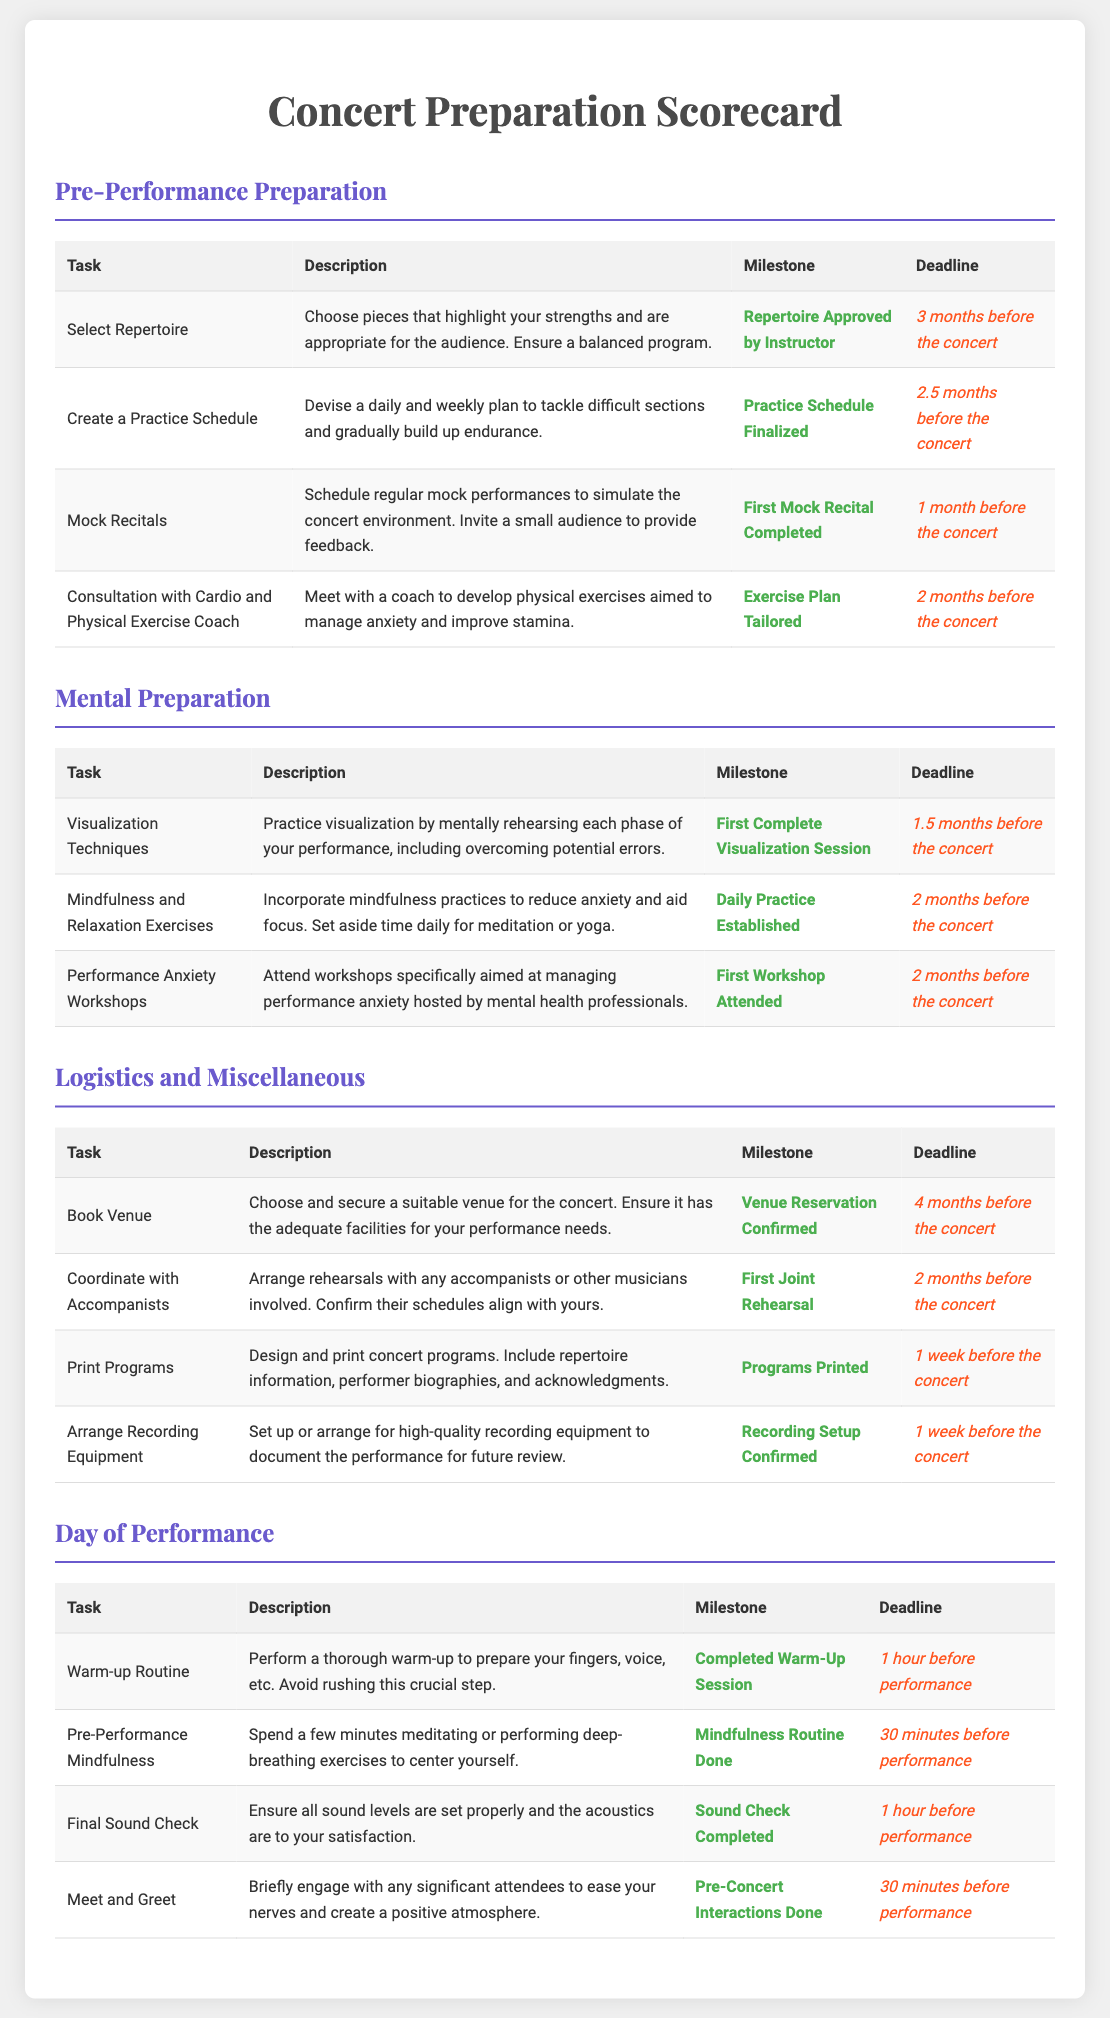what is the deadline for repertoire approval? The deadline for repertoire approval is noted in the pre-performance preparation section as three months before the concert.
Answer: 3 months before the concert what task requires coordination with accompanists? The task that involves coordination with accompanists is found under logistics and miscellaneous, and it requires arranging rehearsals with any accompanists or musicians.
Answer: Coordinate with Accompanists which mental preparation task has a milestone of "First Complete Visualization Session"? This milestone is related to the task of practicing visualization techniques, as detailed in the mental preparation section of the document.
Answer: Visualization Techniques how many mock recitals need to be completed before the concert? The document specifies the completion of the first mock recital as a milestone in the pre-performance preparation section.
Answer: First Mock Recital Completed what is the task due one week before the concert related to printed materials? The task mentioned in the logistics and miscellaneous section related to printed materials is to design and print concert programs, which must be finished a week before the concert.
Answer: Print Programs what is the description of the warm-up routine task? The warm-up routine involves performing a thorough warm-up to prepare your fingers, voice, etc., and emphasizes avoiding rushing this crucial step.
Answer: Perform a thorough warm-up to prepare your fingers, voice, etc which task aims to improve focus and reduce anxiety? The task aimed at improving focus and reducing anxiety is the incorporation of mindfulness practices as noted in the mental preparation section.
Answer: Mindfulness and Relaxation Exercises what needs to be confirmed one week before the concert related to audio? The document states that the recording setup must be confirmed one week before the concert as part of the logistics and miscellaneous section.
Answer: Recording Setup Confirmed 